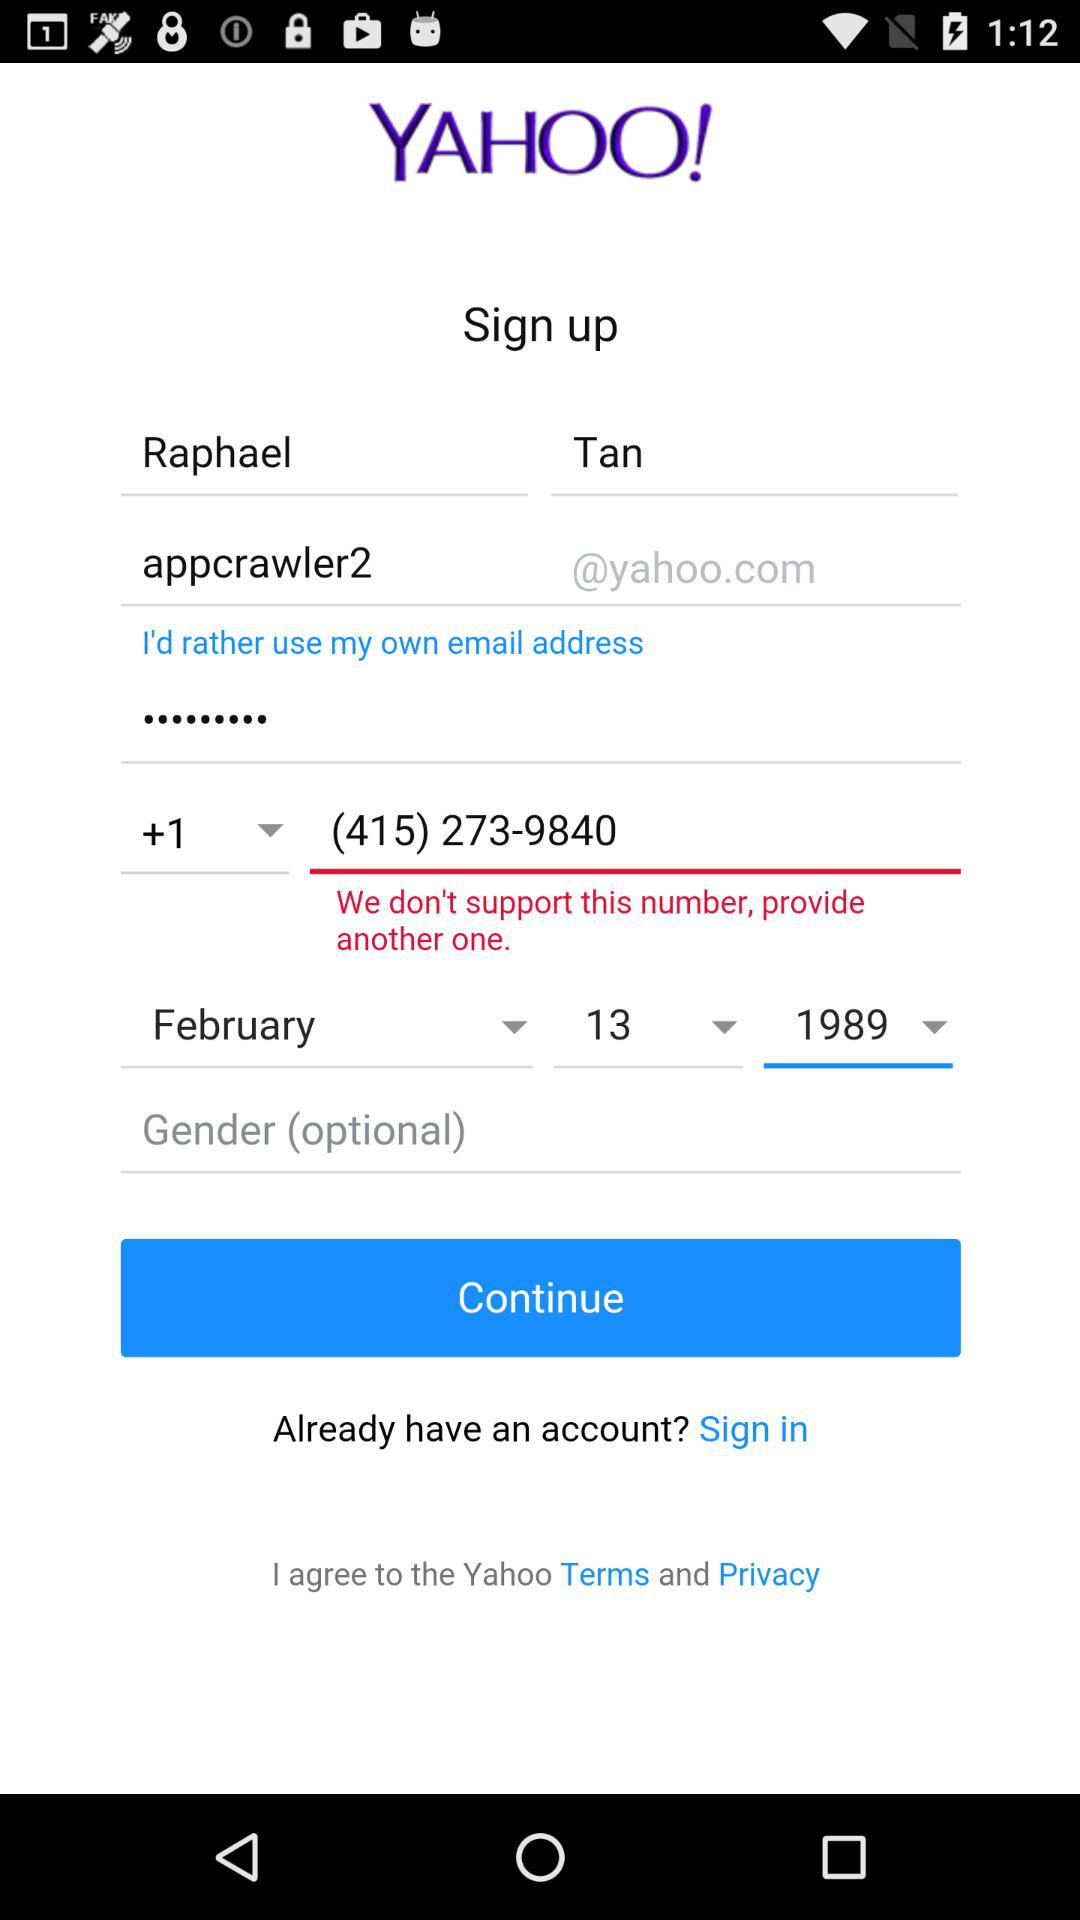What is the phone number? The phone number is (415) 273-9840. 